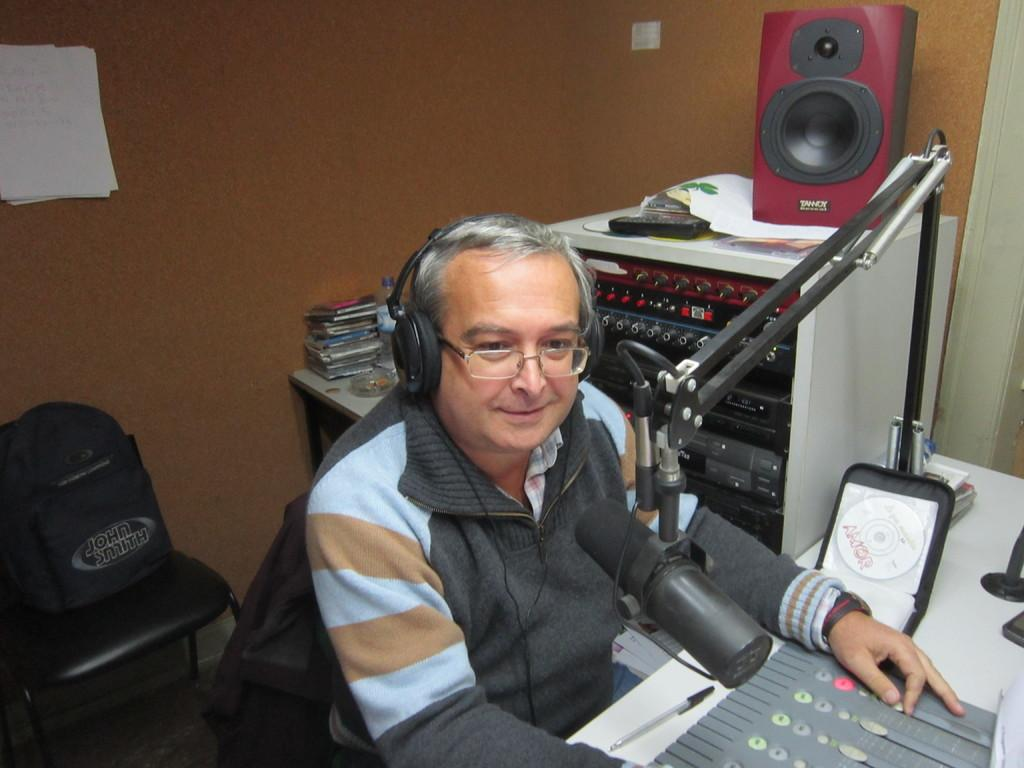What is the man in the image doing? There is a man sitting in the image. What equipment is visible in the image? There are headsets, a sound box, and a microphone in the image. What is the man sitting on in the image? There is a chair in the image. How does the sponge stop the twist in the image? There is no sponge or twist present in the image. 